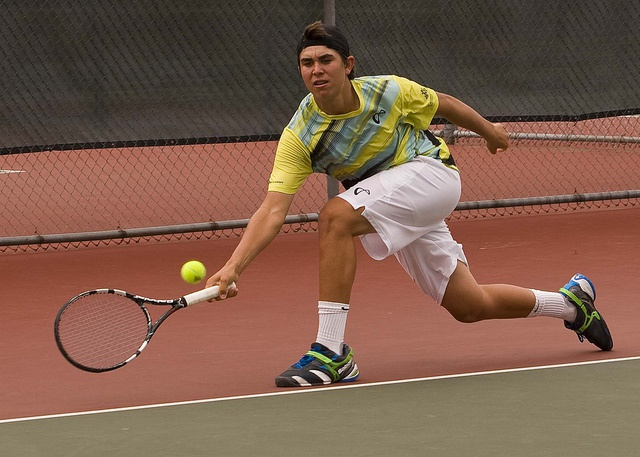Describe the objects in this image and their specific colors. I can see people in black, brown, olive, and maroon tones, tennis racket in black, brown, maroon, and lightgray tones, and sports ball in black, khaki, olive, and yellow tones in this image. 